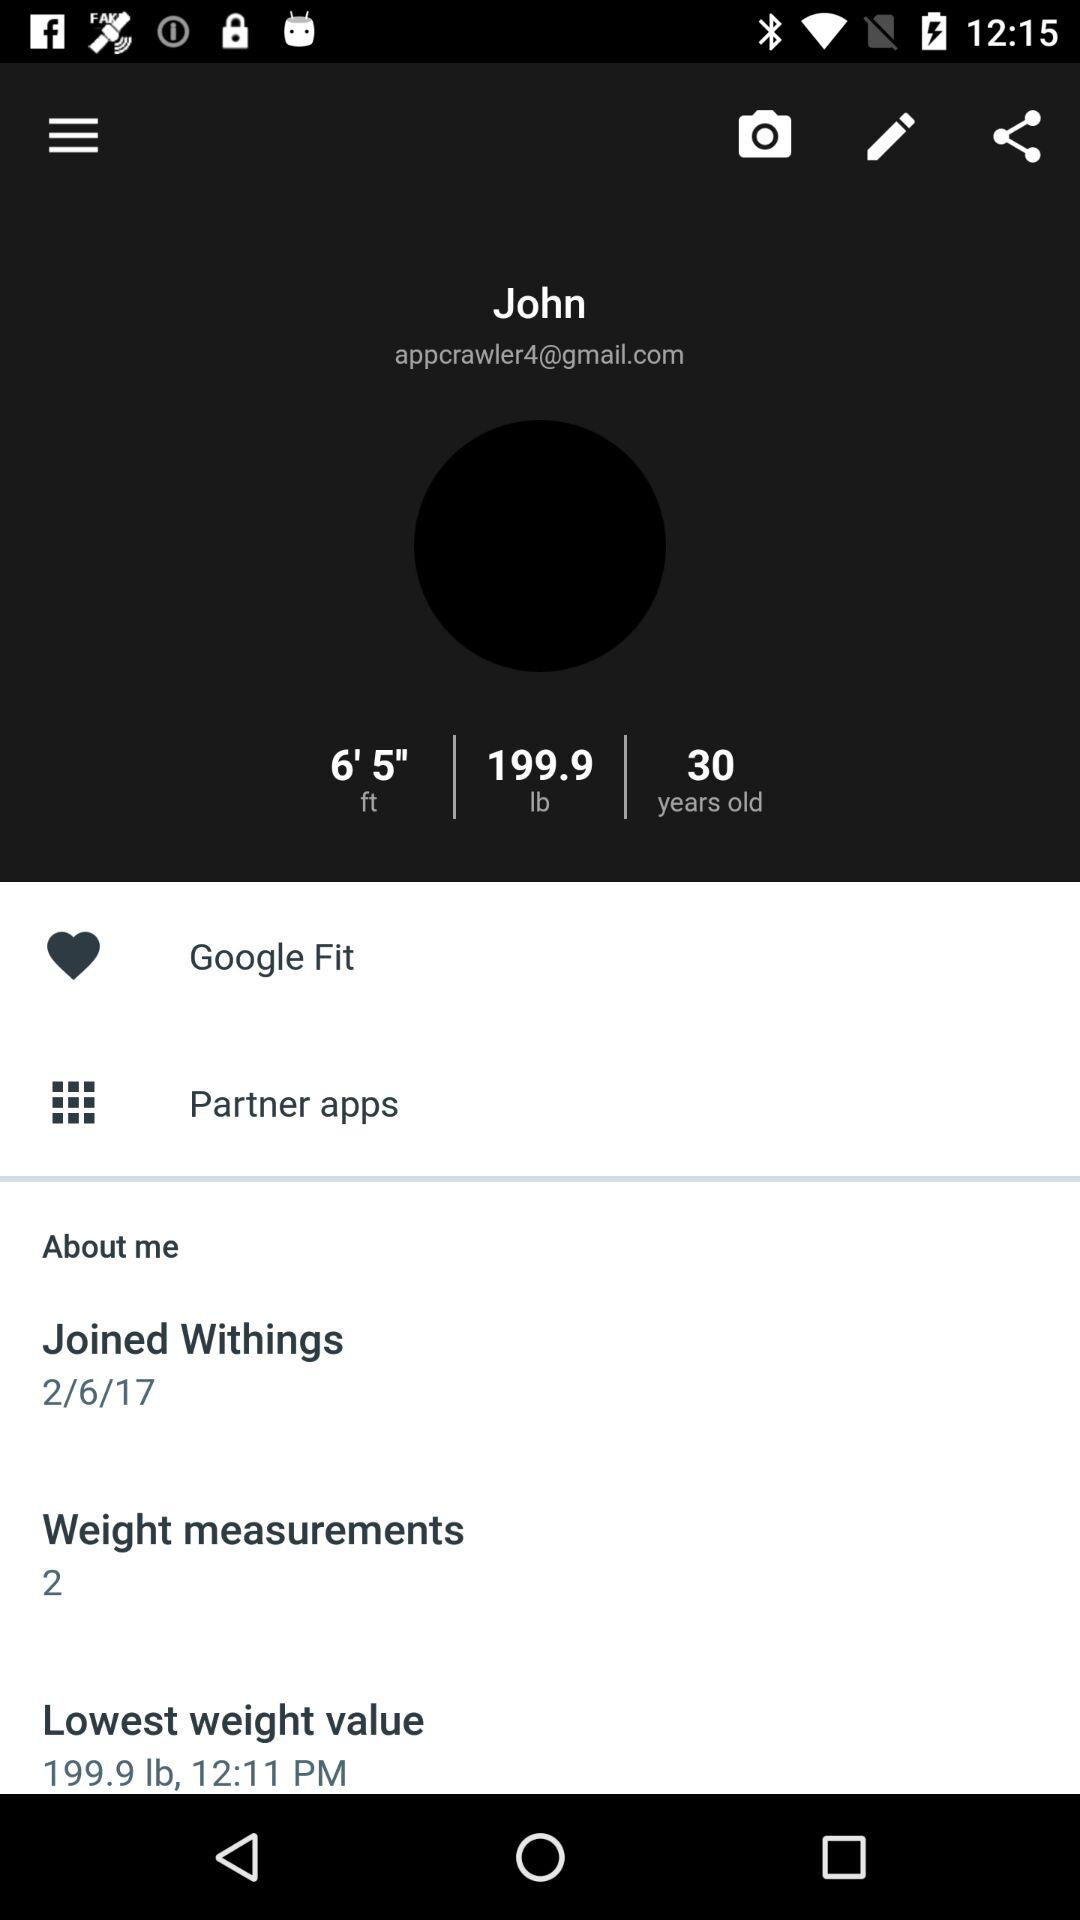How many weight measurements are there? There are two weight measurements. 